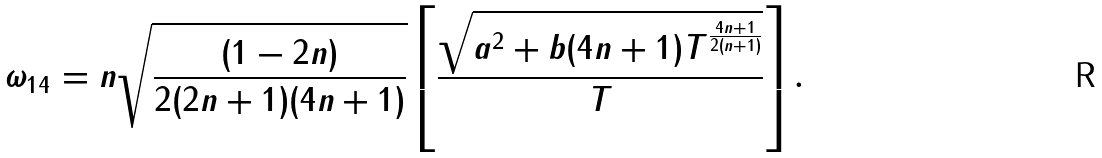<formula> <loc_0><loc_0><loc_500><loc_500>\omega _ { 1 4 } = n \sqrt { \frac { ( 1 - 2 n ) } { 2 ( 2 n + 1 ) ( 4 n + 1 ) } } \left [ \frac { \sqrt { a ^ { 2 } + b ( 4 n + 1 ) T ^ { \frac { 4 n + 1 } { 2 ( n + 1 ) } } } } { T } \right ] .</formula> 